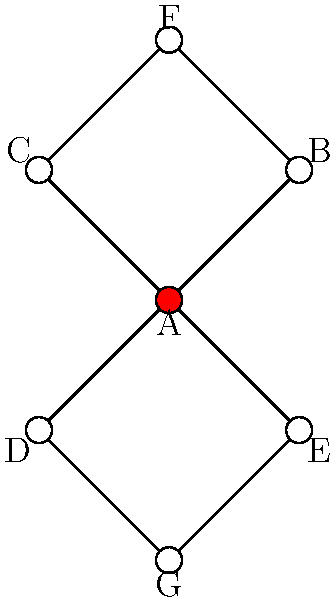In the given social media network graph, user A is suspected of operating multiple hidden profiles. Based on the connection patterns, which two profiles are most likely to be A's hidden accounts? To identify potential hidden profiles of user A, we need to analyze the graph structure and connection patterns:

1. User A (red node) is directly connected to users B, C, D, and E.
2. Users F and G are not directly connected to A.
3. F is connected to both B and C, while G is connected to both D and E.
4. This creates a symmetrical pattern where F and G have identical connection structures in relation to A's direct connections.

The symmetry and indirect connections suggest that F and G might be hidden profiles of A because:

1. They maintain separation from A's main profile (no direct connections).
2. They each connect to two of A's direct connections, allowing indirect information flow.
3. The symmetrical structure could be an attempt to balance and disguise the hidden profiles' activities.

This pattern is consistent with a strategy to maintain hidden profiles while still having access to information from the main profile's network.
Answer: F and G 